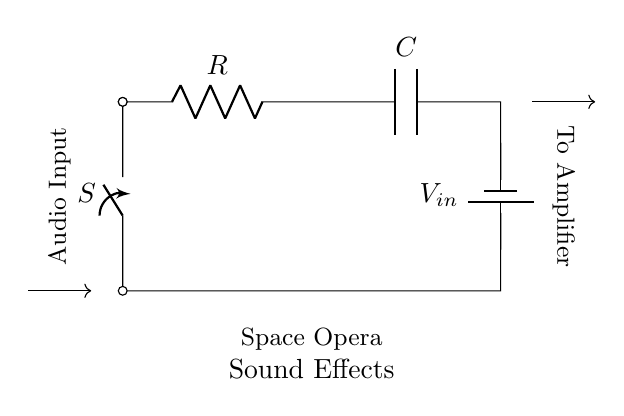What are the components in this circuit? The circuit diagram displays a resistor, a capacitor, a battery, and a switch. These are the main components involved in a series RC circuit.
Answer: Resistor, Capacitor, Battery, Switch What does the switch control in this circuit? The switch controls the flow of current from the battery to the resistor and capacitor. When the switch is closed, current can flow, allowing the circuit to function.
Answer: Current flow What is the type of circuit shown? This is a series RC circuit, where a resistor and capacitor are connected in series with a voltage source. It’s specifically configured to create sound effects in audio systems.
Answer: Series RC circuit How does this circuit affect audio input? The resistor and capacitor interact to filter the audio input, shaping the sound for effects. The charging and discharging of the capacitor affect the tone and duration of the sound produced.
Answer: Filters sound What is the function of the capacitor in this circuit? The capacitor stores electrical energy and releases it gradually, creating time-dependent effects in the audio output. Its charging time affects the nature of the sound effect.
Answer: Energy storage How is the audio signal ultimately processed? The processed signal from this circuit is sent to an amplifier, where it can be boosted for output. This step enhances the sound effects generated by the combination of the resistor and capacitor.
Answer: Sent to amplifier 